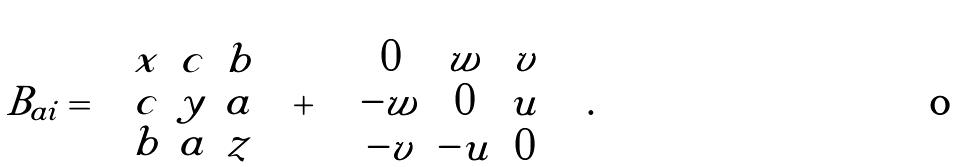Convert formula to latex. <formula><loc_0><loc_0><loc_500><loc_500>B _ { a i } = \left ( \begin{array} { c c c } x & c & b \\ c & y & a \\ b & a & z \\ \end{array} \right ) + \left ( \begin{array} { c c c } 0 & w & v \\ - w & 0 & u \\ - v & - u & 0 \\ \end{array} \right ) .</formula> 